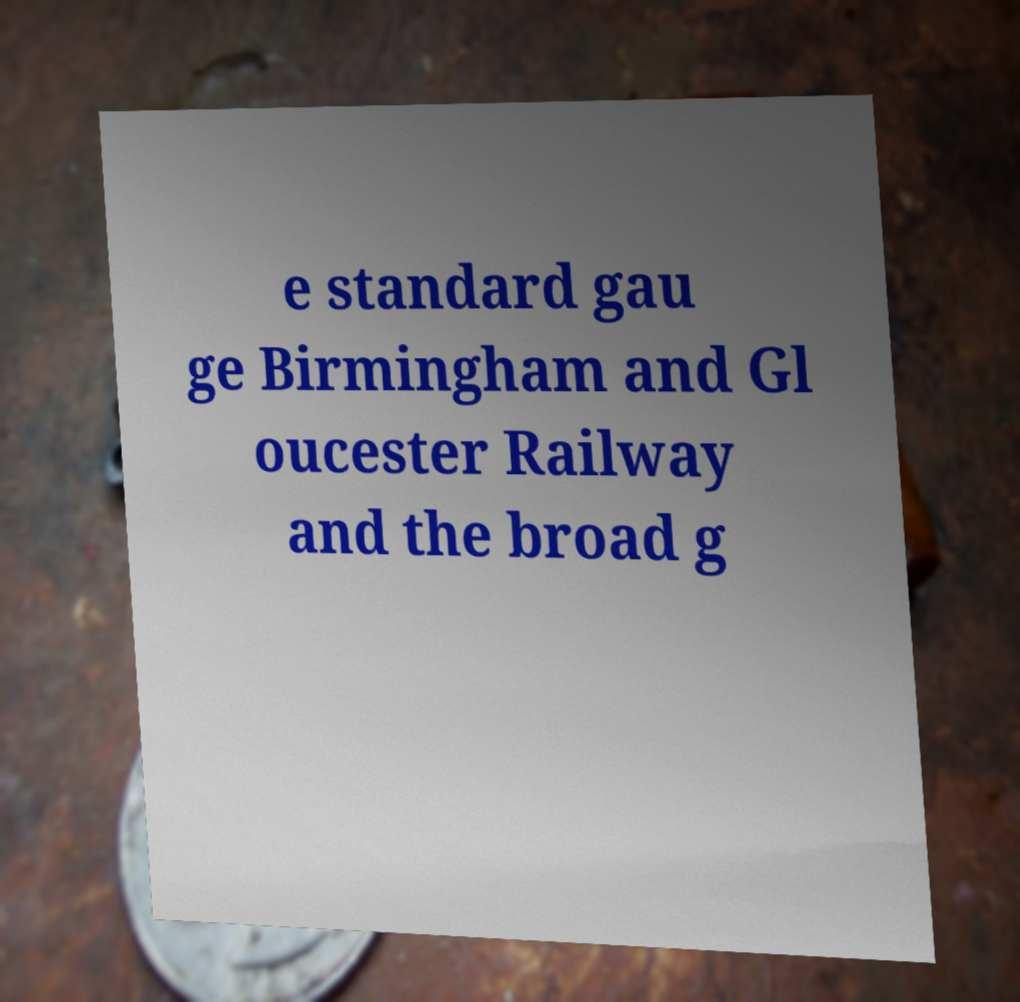Can you read and provide the text displayed in the image?This photo seems to have some interesting text. Can you extract and type it out for me? e standard gau ge Birmingham and Gl oucester Railway and the broad g 